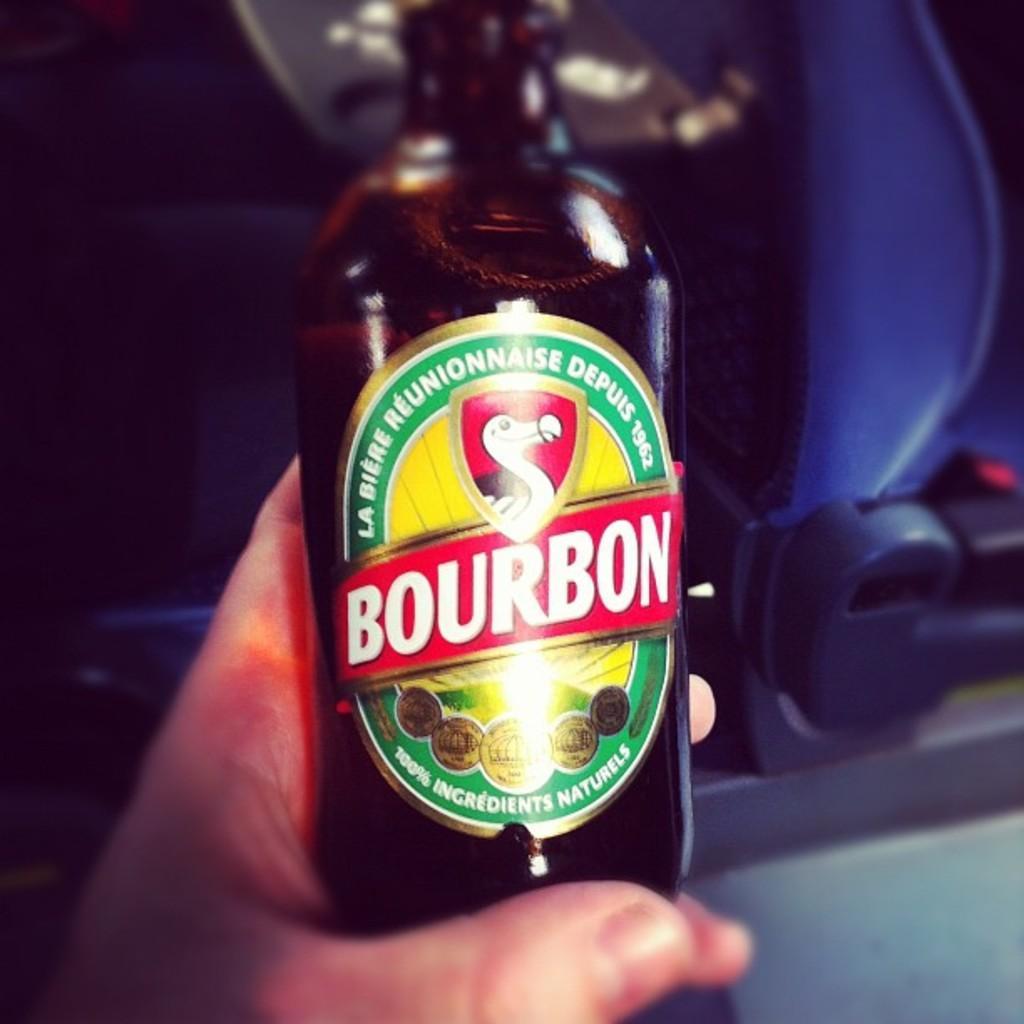Could you give a brief overview of what you see in this image? In this picture we can see bottle with sticker to it and some persons hand is holding it and in background we can see seat and it is dark. 